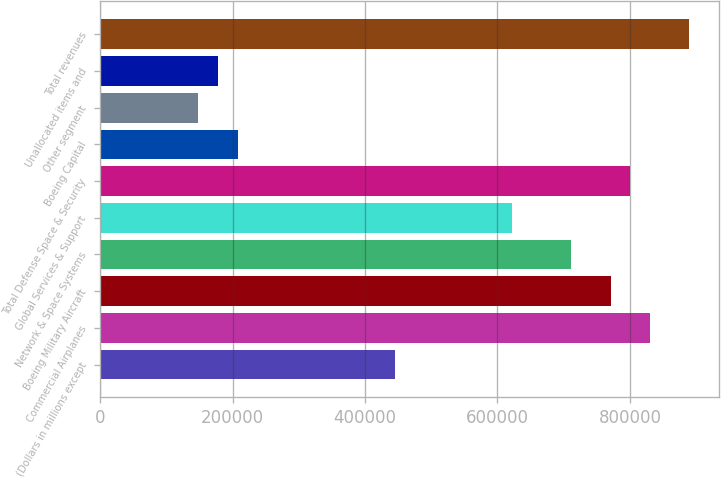Convert chart to OTSL. <chart><loc_0><loc_0><loc_500><loc_500><bar_chart><fcel>(Dollars in millions except<fcel>Commercial Airplanes<fcel>Boeing Military Aircraft<fcel>Network & Space Systems<fcel>Global Services & Support<fcel>Total Defense Space & Security<fcel>Boeing Capital<fcel>Other segment<fcel>Unallocated items and<fcel>Total revenues<nl><fcel>444749<fcel>830197<fcel>770897<fcel>711598<fcel>622648<fcel>800547<fcel>207550<fcel>148251<fcel>177901<fcel>889497<nl></chart> 